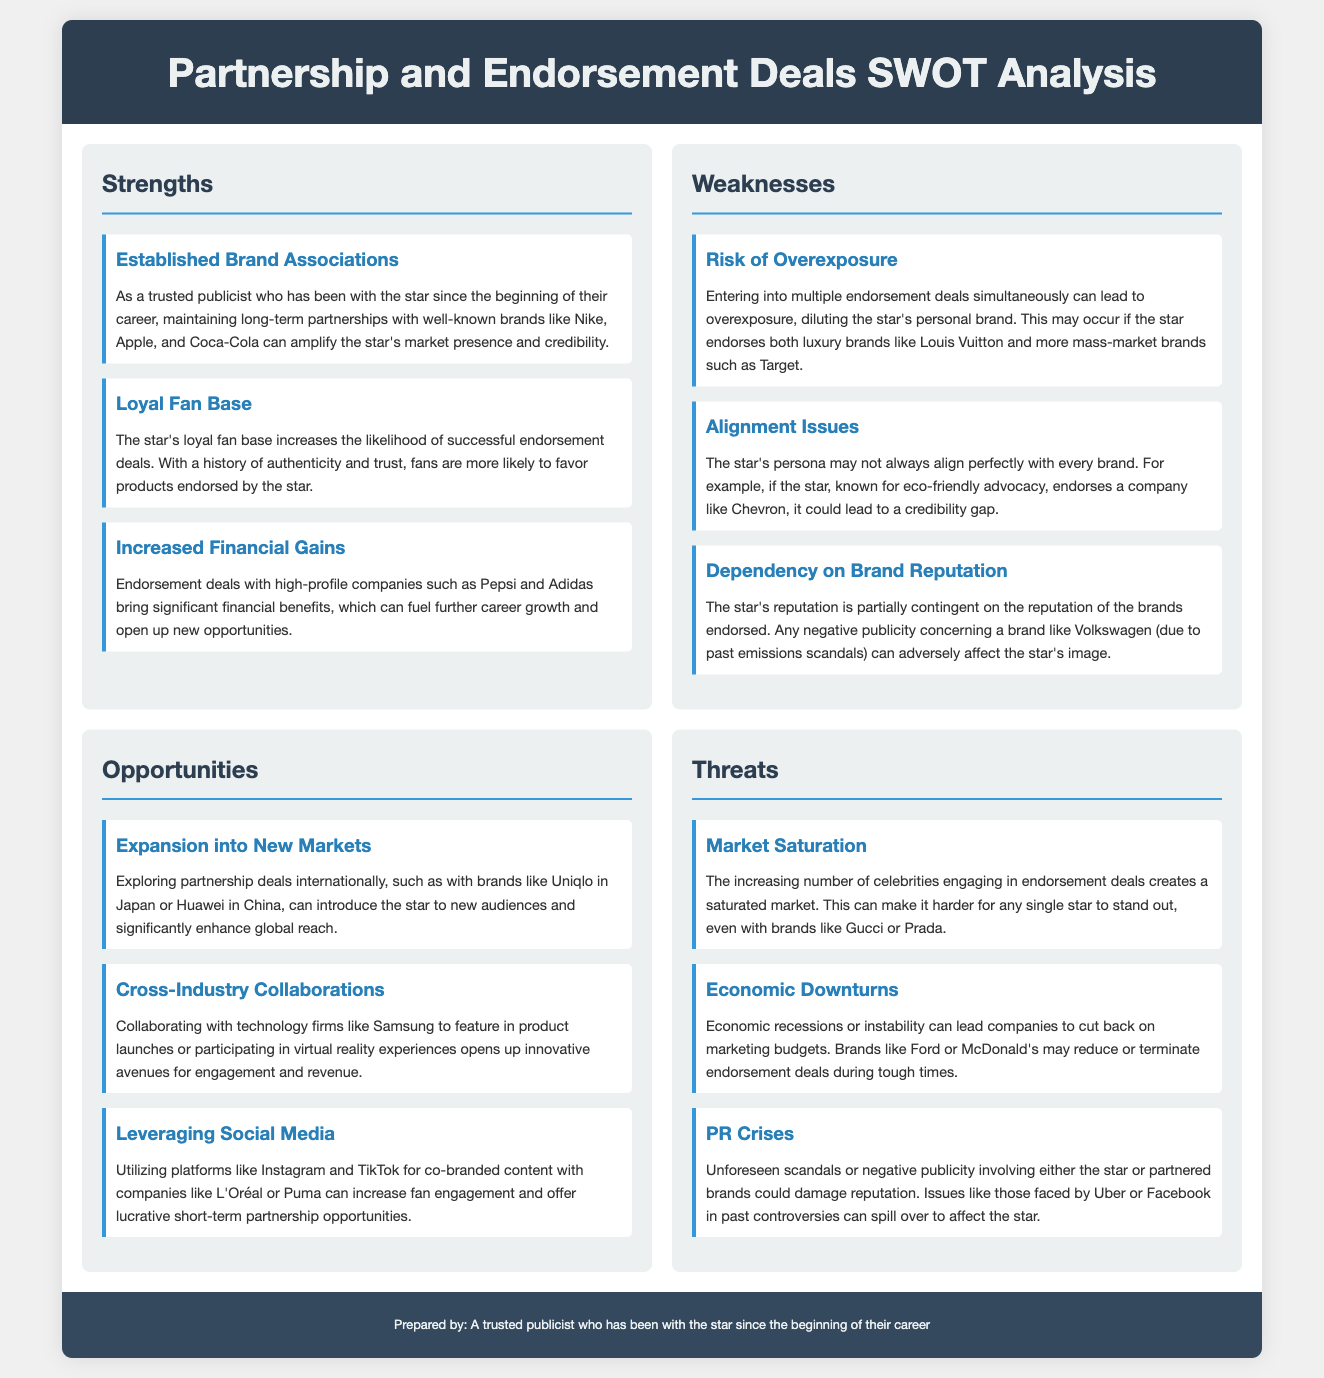What are some established brand associations? The established brand associations mentioned in the document include Nike, Apple, and Coca-Cola, highlighting partnerships that can enhance market presence and credibility.
Answer: Nike, Apple, Coca-Cola What is a potential weakness related to endorsement deals? The document lists potential weaknesses, one of which is the risk of overexposure, occurring from too many simultaneous endorsement deals.
Answer: Risk of Overexposure Which brand is an example of a company that could lead to alignment issues? An example given for alignment issues is Chevron, when endorsed by a star known for eco-friendly advocacy, potentially causing a credibility gap.
Answer: Chevron What opportunity is mentioned for expanding the star's reach? The document suggests exploring partnership deals internationally with brands like Uniqlo in Japan or Huawei in China as a chance to introduce the star to new audiences.
Answer: Uniqlo, Huawei What threat involves negative publicity? The document indicates that PR crises can damage reputation, particularly from unforeseen scandals affecting either the star or partnered brands.
Answer: PR Crises How do economic conditions impact endorsement deals? Economic downturns are highlighted as a threat that can prompt companies to reduce or terminate marketing budgets, affecting sponsorship deals.
Answer: Economic Downturns 